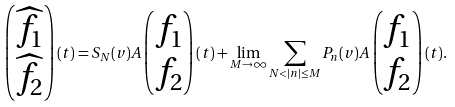<formula> <loc_0><loc_0><loc_500><loc_500>\begin{pmatrix} \widehat { f _ { 1 } } \\ \widehat { f _ { 2 } } \end{pmatrix} ( t ) = S _ { N } ( v ) A \begin{pmatrix} f _ { 1 } \\ f _ { 2 } \end{pmatrix} ( t ) + \lim _ { M \to \infty } \sum _ { N < | n | \leq M } P _ { n } ( v ) A \begin{pmatrix} f _ { 1 } \\ f _ { 2 } \end{pmatrix} ( t ) .</formula> 